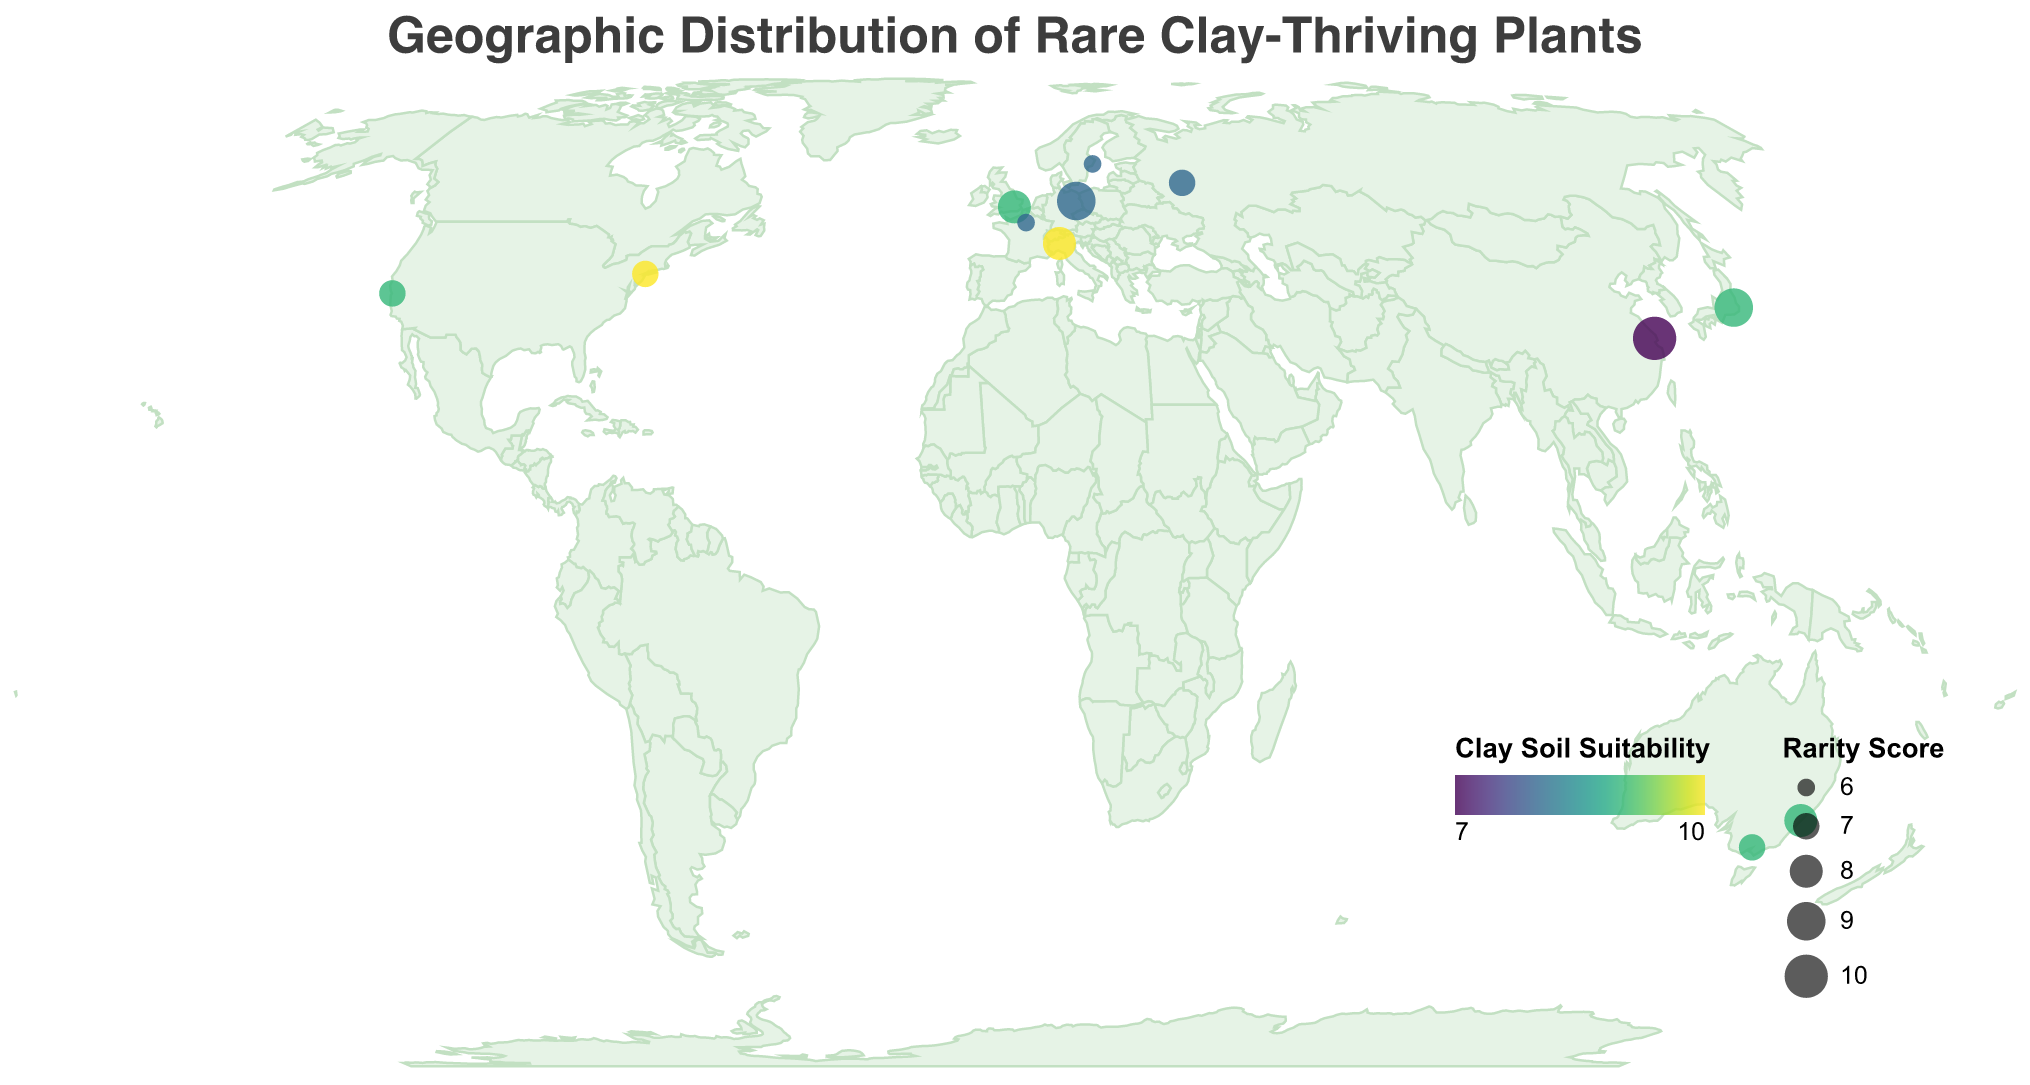What is the title of the geographic plot? The title is typically positioned at the top of the plot. By looking there, you can read it directly.
Answer: Geographic Distribution of Rare Clay-Thriving Plants How many rare plant species are shown on the map? Count the number of different plant species listed in the tooltip or in the data points plotted on the map.
Answer: 12 Which plant species is located in Japan? Look at the data point that is placed over Japan on the map and refer to the tooltip or the item legend to identify the species.
Answer: Tricyrtis hirta Which data point has the highest rarity score? Larger circles indicate higher rarity scores. Identify the largest circle, and use the tooltip to find the corresponding plant species and its rarity score.
Answer: Lithops dorotheae with a rarity score of 10 What’s the average clay soil suitability of all the plants? Sum up all the clay soil suitability scores and divide by the number of data points: (9+10+8+9+8+7+9+8+10+9+8+9)/12 = 103/12
Answer: 8.58 Which plant species has the highest clay soil suitability and where is it located? The tooltip on the data point with the most intense (brightest) color will show the plant species with the highest clay soil suitability.
Answer: Claytonia virginica in New York City Are there any plant species with identical rarity scores and clay soil suitability? Compare data points based on their rarity score and clay soil suitability.
Answer: Yes, Helleborus thibetanus in London and Actinotus helianthi in Sydney both have a rarity score of 8 and clay soil suitability of 9 What is the clay soil suitability range for the plants on the map? Identify the minimum and maximum values of the clay soil suitability field from the data or legend range.
Answer: 7 to 10 Which two plant species are closest in geographical location to each other? Visually assess the proximity of the data points on the map.
Answer: Helleborus thibetanus in London and Cypripedium calceolus in Berlin What color is used to represent the highest clay soil suitability? Look at the legend and find the color indicating the highest value for clay soil suitability.
Answer: Bright green 